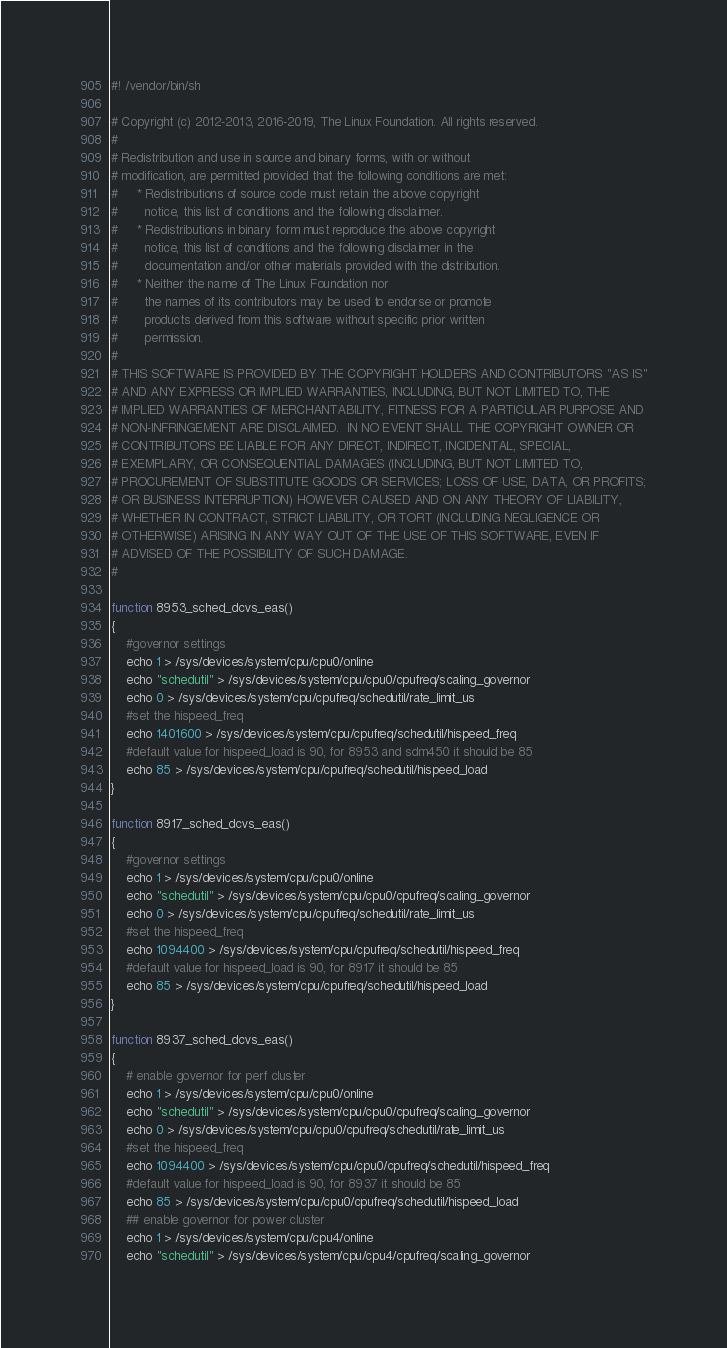Convert code to text. <code><loc_0><loc_0><loc_500><loc_500><_Bash_>#! /vendor/bin/sh

# Copyright (c) 2012-2013, 2016-2019, The Linux Foundation. All rights reserved.
#
# Redistribution and use in source and binary forms, with or without
# modification, are permitted provided that the following conditions are met:
#     * Redistributions of source code must retain the above copyright
#       notice, this list of conditions and the following disclaimer.
#     * Redistributions in binary form must reproduce the above copyright
#       notice, this list of conditions and the following disclaimer in the
#       documentation and/or other materials provided with the distribution.
#     * Neither the name of The Linux Foundation nor
#       the names of its contributors may be used to endorse or promote
#       products derived from this software without specific prior written
#       permission.
#
# THIS SOFTWARE IS PROVIDED BY THE COPYRIGHT HOLDERS AND CONTRIBUTORS "AS IS"
# AND ANY EXPRESS OR IMPLIED WARRANTIES, INCLUDING, BUT NOT LIMITED TO, THE
# IMPLIED WARRANTIES OF MERCHANTABILITY, FITNESS FOR A PARTICULAR PURPOSE AND
# NON-INFRINGEMENT ARE DISCLAIMED.  IN NO EVENT SHALL THE COPYRIGHT OWNER OR
# CONTRIBUTORS BE LIABLE FOR ANY DIRECT, INDIRECT, INCIDENTAL, SPECIAL,
# EXEMPLARY, OR CONSEQUENTIAL DAMAGES (INCLUDING, BUT NOT LIMITED TO,
# PROCUREMENT OF SUBSTITUTE GOODS OR SERVICES; LOSS OF USE, DATA, OR PROFITS;
# OR BUSINESS INTERRUPTION) HOWEVER CAUSED AND ON ANY THEORY OF LIABILITY,
# WHETHER IN CONTRACT, STRICT LIABILITY, OR TORT (INCLUDING NEGLIGENCE OR
# OTHERWISE) ARISING IN ANY WAY OUT OF THE USE OF THIS SOFTWARE, EVEN IF
# ADVISED OF THE POSSIBILITY OF SUCH DAMAGE.
#

function 8953_sched_dcvs_eas()
{
    #governor settings
    echo 1 > /sys/devices/system/cpu/cpu0/online
    echo "schedutil" > /sys/devices/system/cpu/cpu0/cpufreq/scaling_governor
    echo 0 > /sys/devices/system/cpu/cpufreq/schedutil/rate_limit_us
    #set the hispeed_freq
    echo 1401600 > /sys/devices/system/cpu/cpufreq/schedutil/hispeed_freq
    #default value for hispeed_load is 90, for 8953 and sdm450 it should be 85
    echo 85 > /sys/devices/system/cpu/cpufreq/schedutil/hispeed_load
}

function 8917_sched_dcvs_eas()
{
    #governor settings
    echo 1 > /sys/devices/system/cpu/cpu0/online
    echo "schedutil" > /sys/devices/system/cpu/cpu0/cpufreq/scaling_governor
    echo 0 > /sys/devices/system/cpu/cpufreq/schedutil/rate_limit_us
    #set the hispeed_freq
    echo 1094400 > /sys/devices/system/cpu/cpufreq/schedutil/hispeed_freq
    #default value for hispeed_load is 90, for 8917 it should be 85
    echo 85 > /sys/devices/system/cpu/cpufreq/schedutil/hispeed_load
}

function 8937_sched_dcvs_eas()
{
    # enable governor for perf cluster
    echo 1 > /sys/devices/system/cpu/cpu0/online
    echo "schedutil" > /sys/devices/system/cpu/cpu0/cpufreq/scaling_governor
    echo 0 > /sys/devices/system/cpu/cpu0/cpufreq/schedutil/rate_limit_us
    #set the hispeed_freq
    echo 1094400 > /sys/devices/system/cpu/cpu0/cpufreq/schedutil/hispeed_freq
    #default value for hispeed_load is 90, for 8937 it should be 85
    echo 85 > /sys/devices/system/cpu/cpu0/cpufreq/schedutil/hispeed_load
    ## enable governor for power cluster
    echo 1 > /sys/devices/system/cpu/cpu4/online
    echo "schedutil" > /sys/devices/system/cpu/cpu4/cpufreq/scaling_governor</code> 